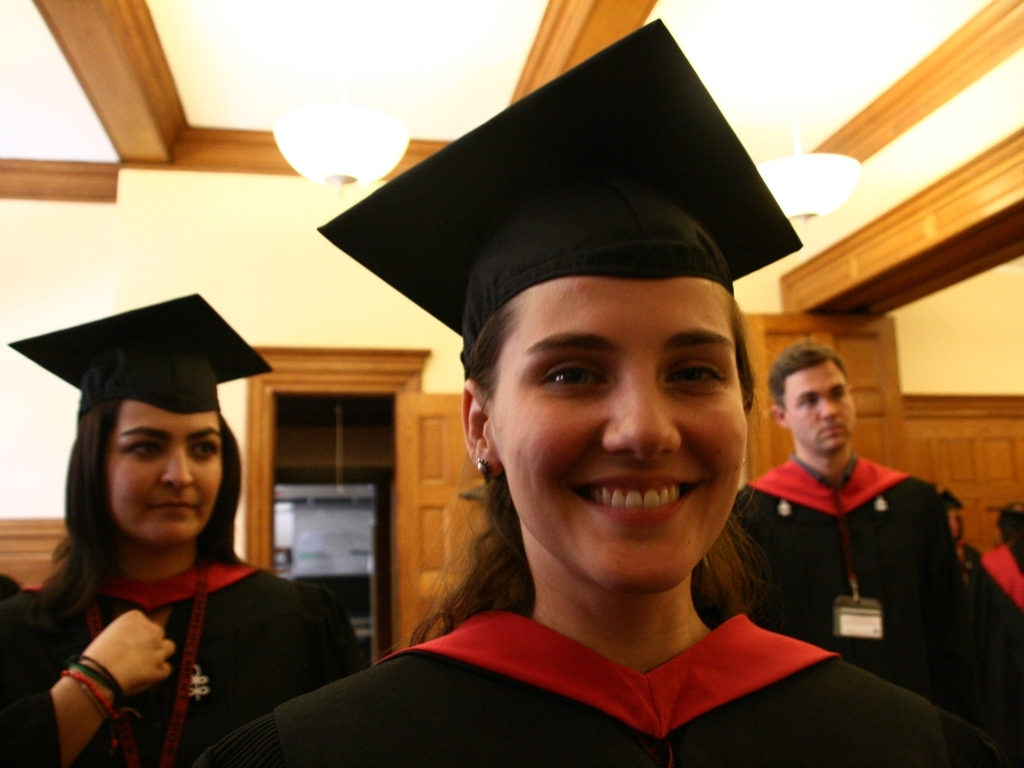What details in this image suggest it was taken indoors? The wooden panels on the walls and the style of the lighting fixtures suggest an indoor setting, likely a hall or an auditorium. These are common in institutional buildings, which align with the context of a graduation ceremony. 